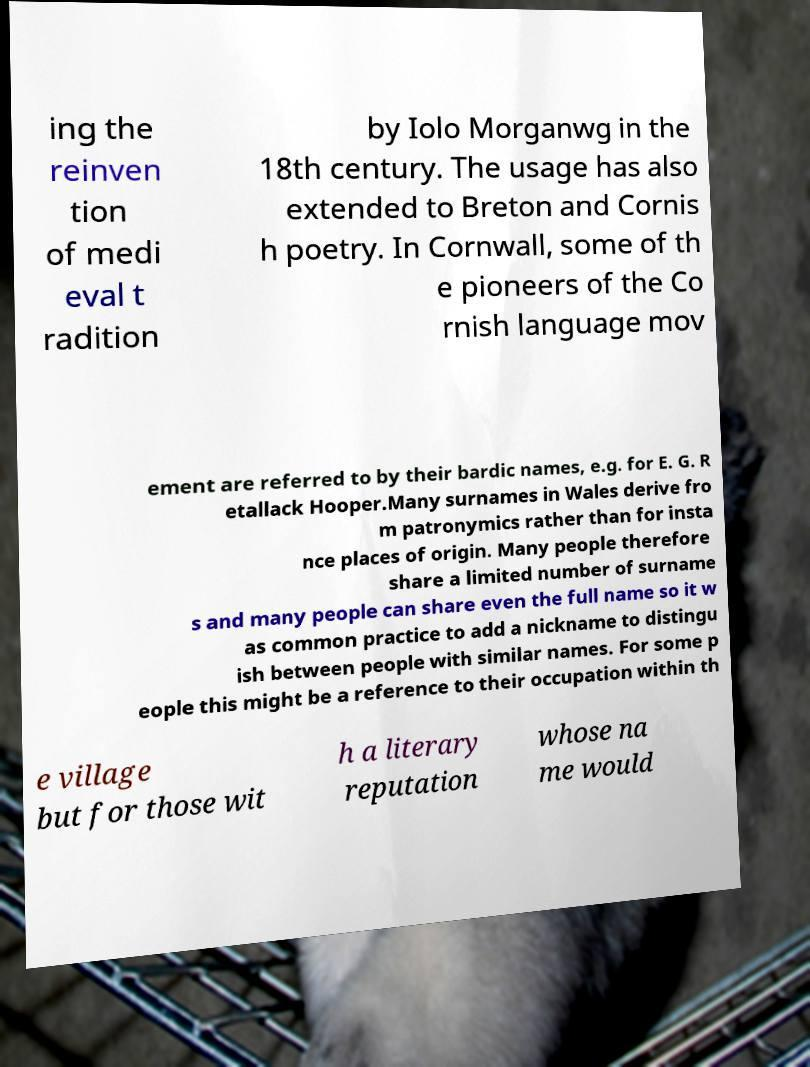I need the written content from this picture converted into text. Can you do that? ing the reinven tion of medi eval t radition by Iolo Morganwg in the 18th century. The usage has also extended to Breton and Cornis h poetry. In Cornwall, some of th e pioneers of the Co rnish language mov ement are referred to by their bardic names, e.g. for E. G. R etallack Hooper.Many surnames in Wales derive fro m patronymics rather than for insta nce places of origin. Many people therefore share a limited number of surname s and many people can share even the full name so it w as common practice to add a nickname to distingu ish between people with similar names. For some p eople this might be a reference to their occupation within th e village but for those wit h a literary reputation whose na me would 